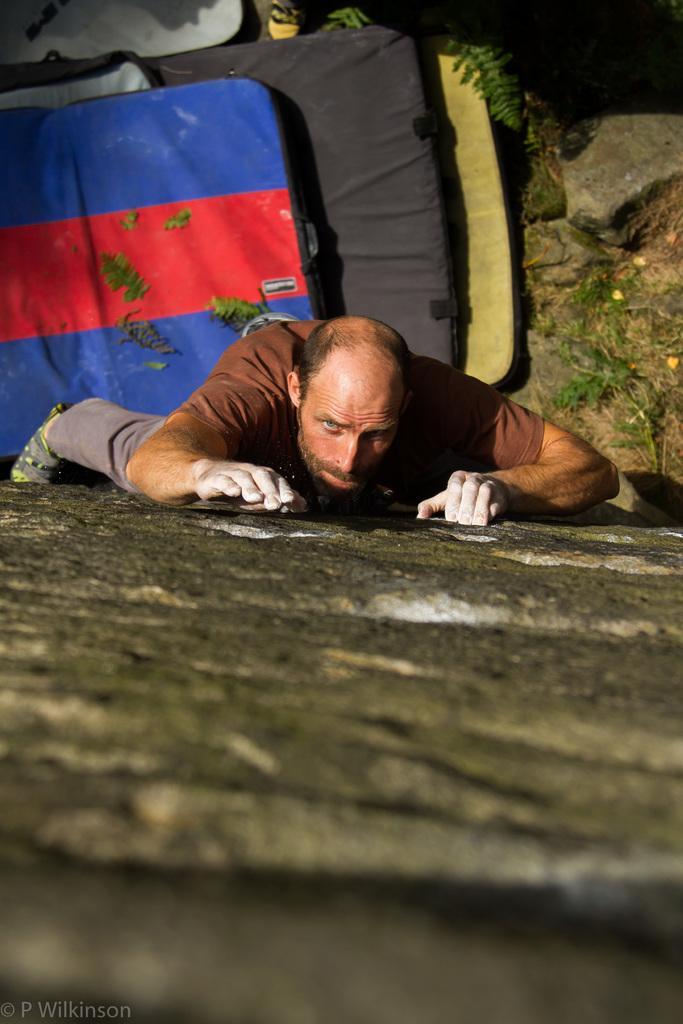Can you describe this image briefly? In this image there is a person climbing the rock. At the bottom of the image there are beds. There is some text on the left side of the image. 